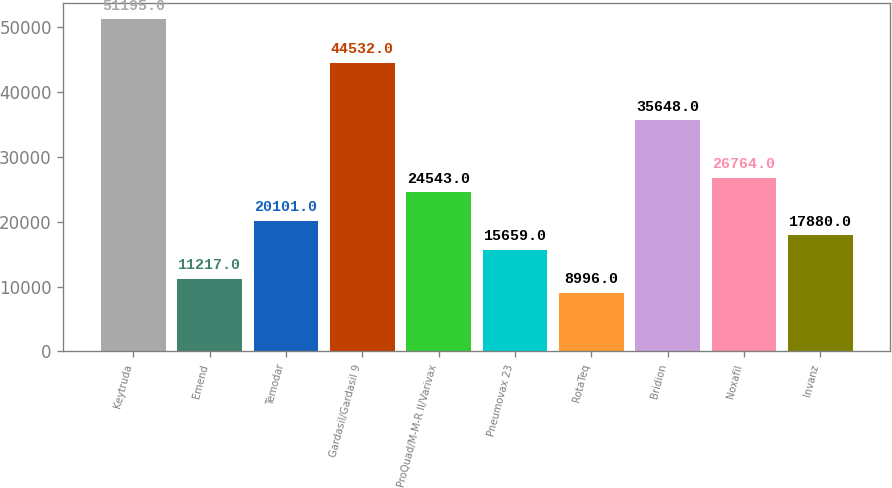<chart> <loc_0><loc_0><loc_500><loc_500><bar_chart><fcel>Keytruda<fcel>Emend<fcel>Temodar<fcel>Gardasil/Gardasil 9<fcel>ProQuad/M-M-R II/Varivax<fcel>Pneumovax 23<fcel>RotaTeq<fcel>Bridion<fcel>Noxafil<fcel>Invanz<nl><fcel>51195<fcel>11217<fcel>20101<fcel>44532<fcel>24543<fcel>15659<fcel>8996<fcel>35648<fcel>26764<fcel>17880<nl></chart> 